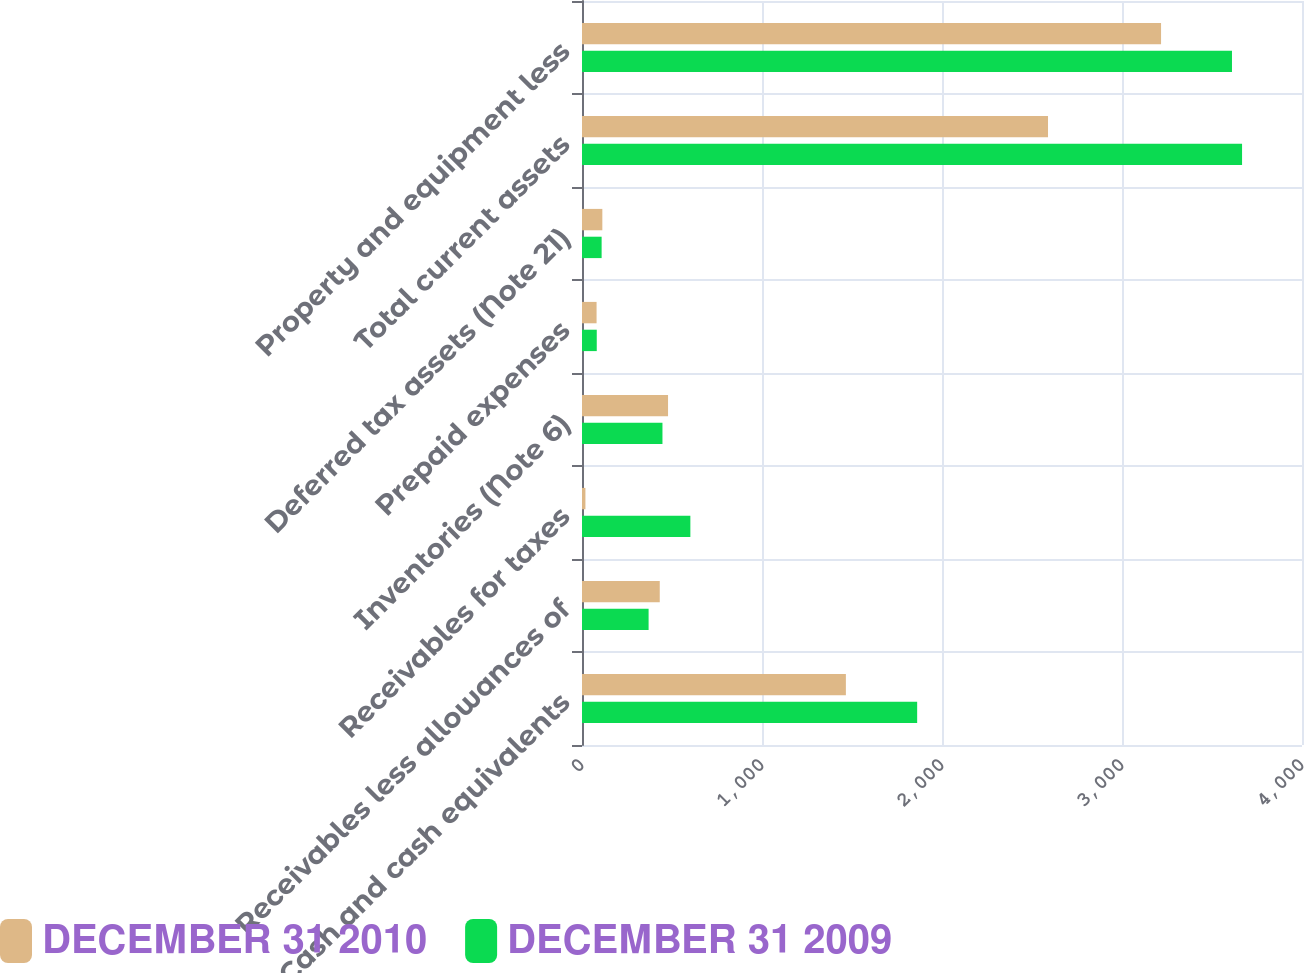<chart> <loc_0><loc_0><loc_500><loc_500><stacked_bar_chart><ecel><fcel>Cash and cash equivalents<fcel>Receivables less allowances of<fcel>Receivables for taxes<fcel>Inventories (Note 6)<fcel>Prepaid expenses<fcel>Deferred tax assets (Note 21)<fcel>Total current assets<fcel>Property and equipment less<nl><fcel>DECEMBER 31 2010<fcel>1466<fcel>432<fcel>19<fcel>478<fcel>81<fcel>113<fcel>2589<fcel>3217<nl><fcel>DECEMBER 31 2009<fcel>1862<fcel>370<fcel>602<fcel>447<fcel>82<fcel>109<fcel>3667<fcel>3611<nl></chart> 